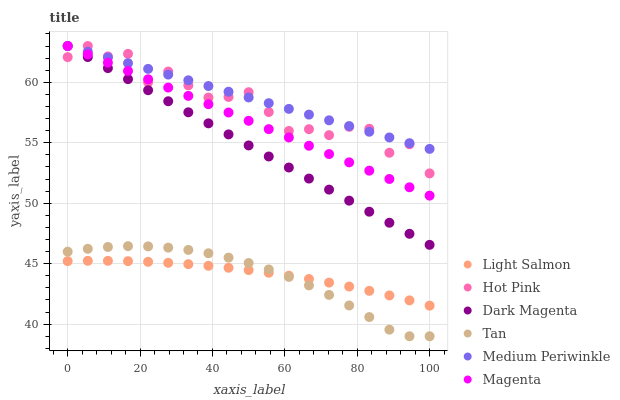Does Tan have the minimum area under the curve?
Answer yes or no. Yes. Does Medium Periwinkle have the maximum area under the curve?
Answer yes or no. Yes. Does Dark Magenta have the minimum area under the curve?
Answer yes or no. No. Does Dark Magenta have the maximum area under the curve?
Answer yes or no. No. Is Dark Magenta the smoothest?
Answer yes or no. Yes. Is Hot Pink the roughest?
Answer yes or no. Yes. Is Hot Pink the smoothest?
Answer yes or no. No. Is Dark Magenta the roughest?
Answer yes or no. No. Does Tan have the lowest value?
Answer yes or no. Yes. Does Dark Magenta have the lowest value?
Answer yes or no. No. Does Magenta have the highest value?
Answer yes or no. Yes. Does Tan have the highest value?
Answer yes or no. No. Is Tan less than Hot Pink?
Answer yes or no. Yes. Is Dark Magenta greater than Tan?
Answer yes or no. Yes. Does Magenta intersect Hot Pink?
Answer yes or no. Yes. Is Magenta less than Hot Pink?
Answer yes or no. No. Is Magenta greater than Hot Pink?
Answer yes or no. No. Does Tan intersect Hot Pink?
Answer yes or no. No. 